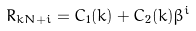Convert formula to latex. <formula><loc_0><loc_0><loc_500><loc_500>R _ { k N + i } = C _ { 1 } ( k ) + C _ { 2 } ( k ) \beta ^ { i }</formula> 